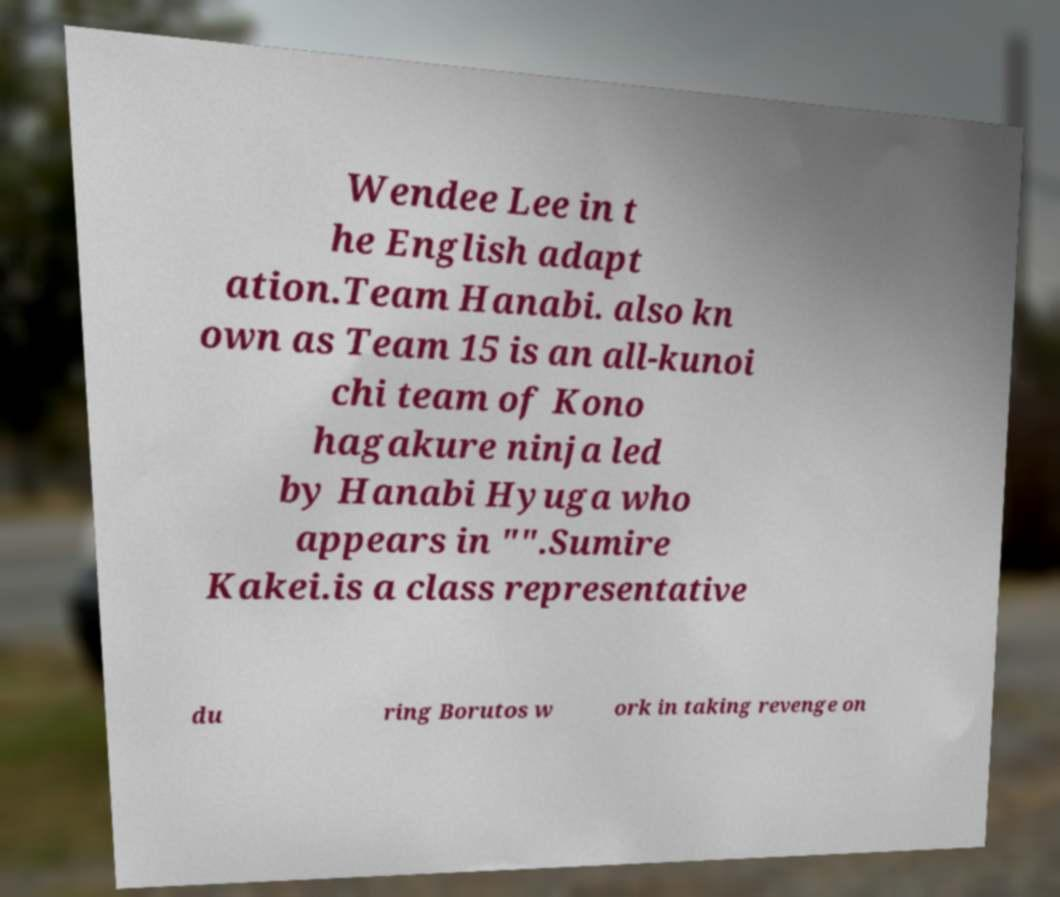For documentation purposes, I need the text within this image transcribed. Could you provide that? Wendee Lee in t he English adapt ation.Team Hanabi. also kn own as Team 15 is an all-kunoi chi team of Kono hagakure ninja led by Hanabi Hyuga who appears in "".Sumire Kakei.is a class representative du ring Borutos w ork in taking revenge on 